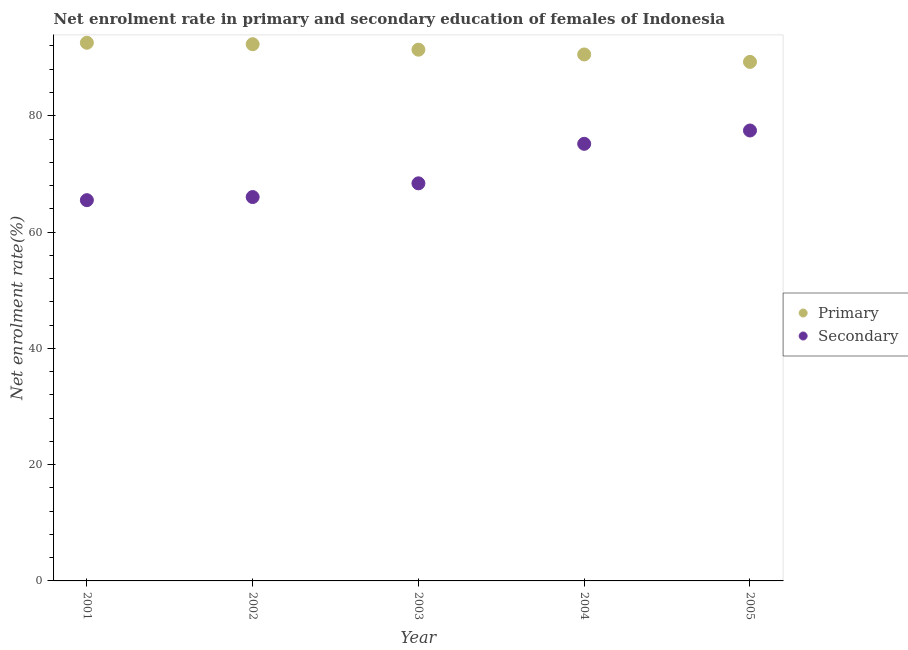Is the number of dotlines equal to the number of legend labels?
Make the answer very short. Yes. What is the enrollment rate in secondary education in 2002?
Provide a short and direct response. 66.02. Across all years, what is the maximum enrollment rate in secondary education?
Your answer should be compact. 77.46. Across all years, what is the minimum enrollment rate in secondary education?
Offer a very short reply. 65.48. In which year was the enrollment rate in primary education maximum?
Your answer should be very brief. 2001. What is the total enrollment rate in secondary education in the graph?
Offer a very short reply. 352.51. What is the difference between the enrollment rate in primary education in 2001 and that in 2003?
Keep it short and to the point. 1.19. What is the difference between the enrollment rate in secondary education in 2003 and the enrollment rate in primary education in 2001?
Ensure brevity in your answer.  -24.18. What is the average enrollment rate in primary education per year?
Offer a terse response. 91.2. In the year 2004, what is the difference between the enrollment rate in primary education and enrollment rate in secondary education?
Offer a very short reply. 15.37. In how many years, is the enrollment rate in secondary education greater than 64 %?
Provide a succinct answer. 5. What is the ratio of the enrollment rate in primary education in 2001 to that in 2004?
Offer a very short reply. 1.02. Is the enrollment rate in primary education in 2003 less than that in 2005?
Provide a succinct answer. No. Is the difference between the enrollment rate in secondary education in 2003 and 2005 greater than the difference between the enrollment rate in primary education in 2003 and 2005?
Provide a succinct answer. No. What is the difference between the highest and the second highest enrollment rate in secondary education?
Keep it short and to the point. 2.29. What is the difference between the highest and the lowest enrollment rate in primary education?
Ensure brevity in your answer.  3.29. In how many years, is the enrollment rate in secondary education greater than the average enrollment rate in secondary education taken over all years?
Provide a succinct answer. 2. How many dotlines are there?
Provide a succinct answer. 2. How many years are there in the graph?
Provide a short and direct response. 5. What is the difference between two consecutive major ticks on the Y-axis?
Your answer should be compact. 20. Are the values on the major ticks of Y-axis written in scientific E-notation?
Offer a terse response. No. Does the graph contain grids?
Provide a succinct answer. No. Where does the legend appear in the graph?
Keep it short and to the point. Center right. How many legend labels are there?
Keep it short and to the point. 2. What is the title of the graph?
Give a very brief answer. Net enrolment rate in primary and secondary education of females of Indonesia. Does "Lowest 10% of population" appear as one of the legend labels in the graph?
Your response must be concise. No. What is the label or title of the Y-axis?
Make the answer very short. Net enrolment rate(%). What is the Net enrolment rate(%) of Primary in 2001?
Give a very brief answer. 92.55. What is the Net enrolment rate(%) in Secondary in 2001?
Your answer should be compact. 65.48. What is the Net enrolment rate(%) in Primary in 2002?
Keep it short and to the point. 92.3. What is the Net enrolment rate(%) of Secondary in 2002?
Offer a terse response. 66.02. What is the Net enrolment rate(%) of Primary in 2003?
Give a very brief answer. 91.36. What is the Net enrolment rate(%) in Secondary in 2003?
Offer a very short reply. 68.38. What is the Net enrolment rate(%) of Primary in 2004?
Ensure brevity in your answer.  90.54. What is the Net enrolment rate(%) in Secondary in 2004?
Keep it short and to the point. 75.17. What is the Net enrolment rate(%) in Primary in 2005?
Provide a succinct answer. 89.26. What is the Net enrolment rate(%) of Secondary in 2005?
Provide a short and direct response. 77.46. Across all years, what is the maximum Net enrolment rate(%) in Primary?
Give a very brief answer. 92.55. Across all years, what is the maximum Net enrolment rate(%) in Secondary?
Your answer should be compact. 77.46. Across all years, what is the minimum Net enrolment rate(%) in Primary?
Your answer should be very brief. 89.26. Across all years, what is the minimum Net enrolment rate(%) of Secondary?
Offer a very short reply. 65.48. What is the total Net enrolment rate(%) in Primary in the graph?
Your answer should be very brief. 456.02. What is the total Net enrolment rate(%) of Secondary in the graph?
Your response must be concise. 352.51. What is the difference between the Net enrolment rate(%) of Primary in 2001 and that in 2002?
Ensure brevity in your answer.  0.25. What is the difference between the Net enrolment rate(%) in Secondary in 2001 and that in 2002?
Your response must be concise. -0.54. What is the difference between the Net enrolment rate(%) of Primary in 2001 and that in 2003?
Ensure brevity in your answer.  1.19. What is the difference between the Net enrolment rate(%) of Secondary in 2001 and that in 2003?
Provide a succinct answer. -2.9. What is the difference between the Net enrolment rate(%) of Primary in 2001 and that in 2004?
Keep it short and to the point. 2.01. What is the difference between the Net enrolment rate(%) in Secondary in 2001 and that in 2004?
Make the answer very short. -9.69. What is the difference between the Net enrolment rate(%) in Primary in 2001 and that in 2005?
Your answer should be compact. 3.29. What is the difference between the Net enrolment rate(%) in Secondary in 2001 and that in 2005?
Provide a succinct answer. -11.98. What is the difference between the Net enrolment rate(%) of Primary in 2002 and that in 2003?
Your answer should be very brief. 0.94. What is the difference between the Net enrolment rate(%) of Secondary in 2002 and that in 2003?
Provide a short and direct response. -2.36. What is the difference between the Net enrolment rate(%) of Primary in 2002 and that in 2004?
Give a very brief answer. 1.76. What is the difference between the Net enrolment rate(%) in Secondary in 2002 and that in 2004?
Offer a terse response. -9.15. What is the difference between the Net enrolment rate(%) of Primary in 2002 and that in 2005?
Provide a short and direct response. 3.04. What is the difference between the Net enrolment rate(%) of Secondary in 2002 and that in 2005?
Your answer should be very brief. -11.44. What is the difference between the Net enrolment rate(%) in Primary in 2003 and that in 2004?
Your answer should be very brief. 0.82. What is the difference between the Net enrolment rate(%) in Secondary in 2003 and that in 2004?
Make the answer very short. -6.8. What is the difference between the Net enrolment rate(%) of Primary in 2003 and that in 2005?
Give a very brief answer. 2.1. What is the difference between the Net enrolment rate(%) of Secondary in 2003 and that in 2005?
Your answer should be compact. -9.09. What is the difference between the Net enrolment rate(%) of Primary in 2004 and that in 2005?
Your answer should be compact. 1.28. What is the difference between the Net enrolment rate(%) in Secondary in 2004 and that in 2005?
Your response must be concise. -2.29. What is the difference between the Net enrolment rate(%) of Primary in 2001 and the Net enrolment rate(%) of Secondary in 2002?
Your answer should be very brief. 26.54. What is the difference between the Net enrolment rate(%) in Primary in 2001 and the Net enrolment rate(%) in Secondary in 2003?
Offer a very short reply. 24.18. What is the difference between the Net enrolment rate(%) of Primary in 2001 and the Net enrolment rate(%) of Secondary in 2004?
Your answer should be very brief. 17.38. What is the difference between the Net enrolment rate(%) in Primary in 2001 and the Net enrolment rate(%) in Secondary in 2005?
Your response must be concise. 15.09. What is the difference between the Net enrolment rate(%) in Primary in 2002 and the Net enrolment rate(%) in Secondary in 2003?
Ensure brevity in your answer.  23.93. What is the difference between the Net enrolment rate(%) in Primary in 2002 and the Net enrolment rate(%) in Secondary in 2004?
Provide a succinct answer. 17.13. What is the difference between the Net enrolment rate(%) in Primary in 2002 and the Net enrolment rate(%) in Secondary in 2005?
Give a very brief answer. 14.84. What is the difference between the Net enrolment rate(%) of Primary in 2003 and the Net enrolment rate(%) of Secondary in 2004?
Make the answer very short. 16.19. What is the difference between the Net enrolment rate(%) in Primary in 2003 and the Net enrolment rate(%) in Secondary in 2005?
Make the answer very short. 13.9. What is the difference between the Net enrolment rate(%) of Primary in 2004 and the Net enrolment rate(%) of Secondary in 2005?
Your answer should be very brief. 13.08. What is the average Net enrolment rate(%) in Primary per year?
Provide a short and direct response. 91.2. What is the average Net enrolment rate(%) in Secondary per year?
Make the answer very short. 70.5. In the year 2001, what is the difference between the Net enrolment rate(%) of Primary and Net enrolment rate(%) of Secondary?
Provide a succinct answer. 27.07. In the year 2002, what is the difference between the Net enrolment rate(%) of Primary and Net enrolment rate(%) of Secondary?
Offer a terse response. 26.28. In the year 2003, what is the difference between the Net enrolment rate(%) in Primary and Net enrolment rate(%) in Secondary?
Your response must be concise. 22.98. In the year 2004, what is the difference between the Net enrolment rate(%) in Primary and Net enrolment rate(%) in Secondary?
Provide a short and direct response. 15.37. In the year 2005, what is the difference between the Net enrolment rate(%) of Primary and Net enrolment rate(%) of Secondary?
Provide a short and direct response. 11.8. What is the ratio of the Net enrolment rate(%) of Primary in 2001 to that in 2002?
Give a very brief answer. 1. What is the ratio of the Net enrolment rate(%) in Primary in 2001 to that in 2003?
Offer a terse response. 1.01. What is the ratio of the Net enrolment rate(%) in Secondary in 2001 to that in 2003?
Offer a terse response. 0.96. What is the ratio of the Net enrolment rate(%) of Primary in 2001 to that in 2004?
Your answer should be compact. 1.02. What is the ratio of the Net enrolment rate(%) of Secondary in 2001 to that in 2004?
Offer a terse response. 0.87. What is the ratio of the Net enrolment rate(%) in Primary in 2001 to that in 2005?
Ensure brevity in your answer.  1.04. What is the ratio of the Net enrolment rate(%) of Secondary in 2001 to that in 2005?
Your answer should be compact. 0.85. What is the ratio of the Net enrolment rate(%) in Primary in 2002 to that in 2003?
Give a very brief answer. 1.01. What is the ratio of the Net enrolment rate(%) in Secondary in 2002 to that in 2003?
Make the answer very short. 0.97. What is the ratio of the Net enrolment rate(%) of Primary in 2002 to that in 2004?
Make the answer very short. 1.02. What is the ratio of the Net enrolment rate(%) of Secondary in 2002 to that in 2004?
Provide a succinct answer. 0.88. What is the ratio of the Net enrolment rate(%) in Primary in 2002 to that in 2005?
Your answer should be very brief. 1.03. What is the ratio of the Net enrolment rate(%) in Secondary in 2002 to that in 2005?
Make the answer very short. 0.85. What is the ratio of the Net enrolment rate(%) in Primary in 2003 to that in 2004?
Your answer should be very brief. 1.01. What is the ratio of the Net enrolment rate(%) of Secondary in 2003 to that in 2004?
Provide a short and direct response. 0.91. What is the ratio of the Net enrolment rate(%) of Primary in 2003 to that in 2005?
Provide a short and direct response. 1.02. What is the ratio of the Net enrolment rate(%) in Secondary in 2003 to that in 2005?
Your response must be concise. 0.88. What is the ratio of the Net enrolment rate(%) of Primary in 2004 to that in 2005?
Your response must be concise. 1.01. What is the ratio of the Net enrolment rate(%) in Secondary in 2004 to that in 2005?
Your answer should be very brief. 0.97. What is the difference between the highest and the second highest Net enrolment rate(%) of Primary?
Offer a very short reply. 0.25. What is the difference between the highest and the second highest Net enrolment rate(%) of Secondary?
Keep it short and to the point. 2.29. What is the difference between the highest and the lowest Net enrolment rate(%) in Primary?
Provide a succinct answer. 3.29. What is the difference between the highest and the lowest Net enrolment rate(%) in Secondary?
Keep it short and to the point. 11.98. 